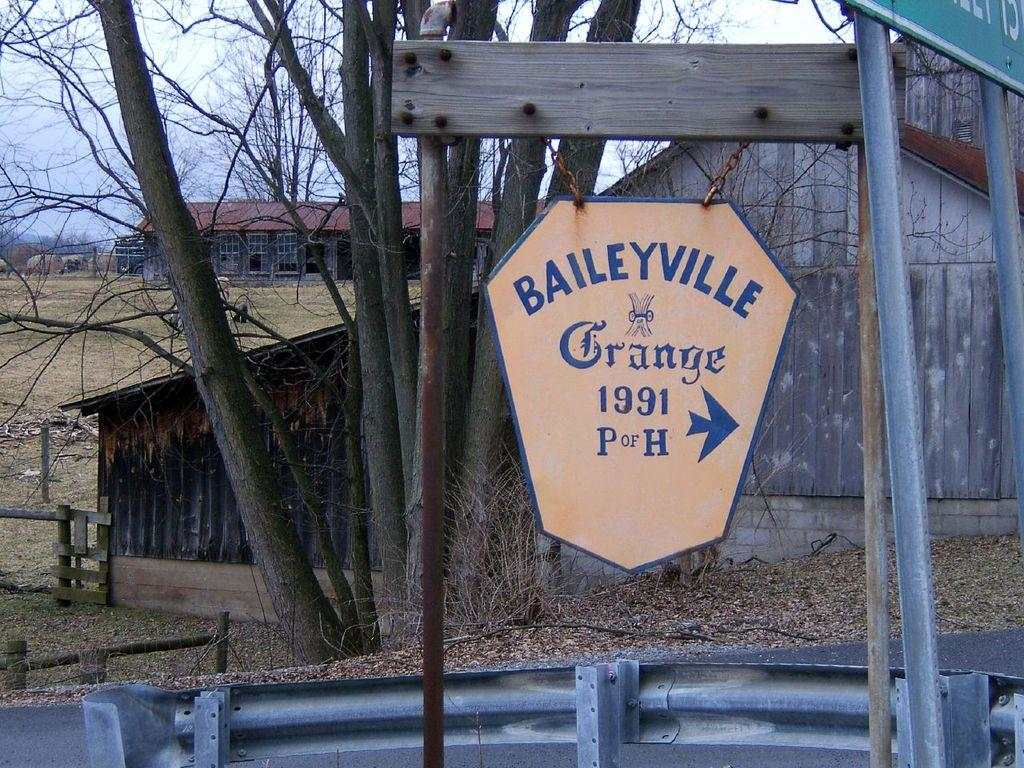What structures are present in the image? There are boards with poles in the image, which resemble sheds. What else can be seen in the image besides the structures? There are trees in the image. What is visible in the background of the image? The sky is visible in the background of the image. What type of bread can be seen hanging from the trees in the image? There is no bread present in the image; it features boards with poles that resemble sheds and trees. 